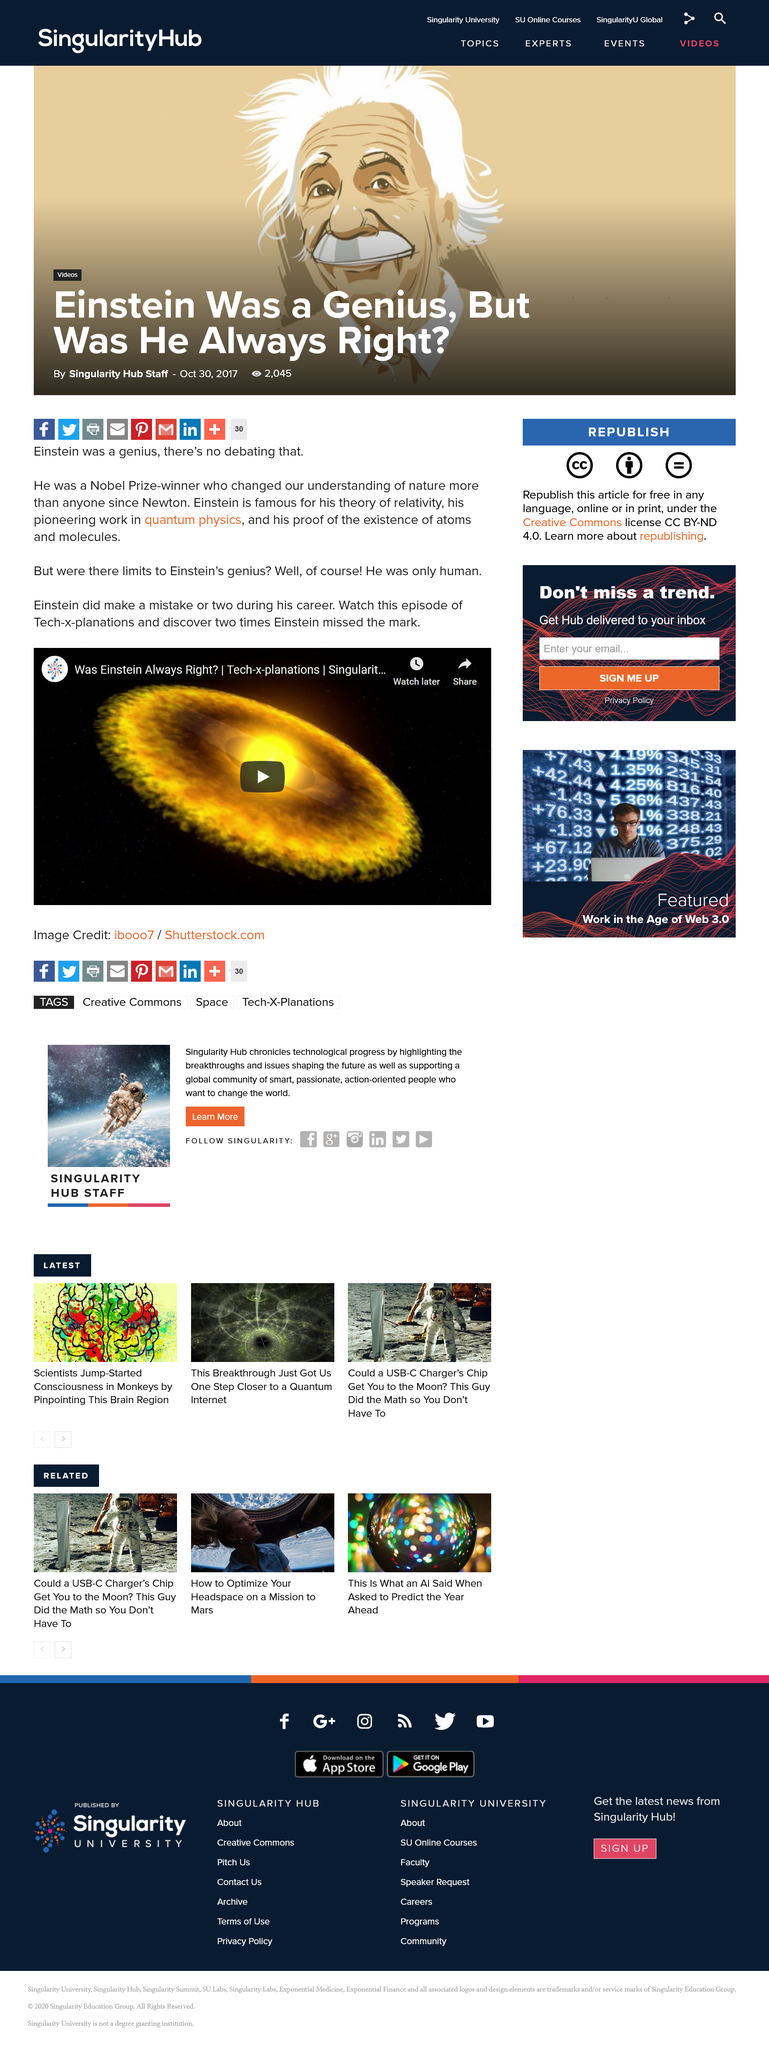Draw attention to some important aspects in this diagram. The provider of the video episode is Tech-x-planations. Einstein is widely recognized for his groundbreaking theory of relativity. Albert Einstein was awarded the Nobel Prize in Physics for his groundbreaking work on the theory of relativity. This prestigious honor recognized his significant contributions to the field of physics and solidified his position as a leading scientific figure of the 20th century. 